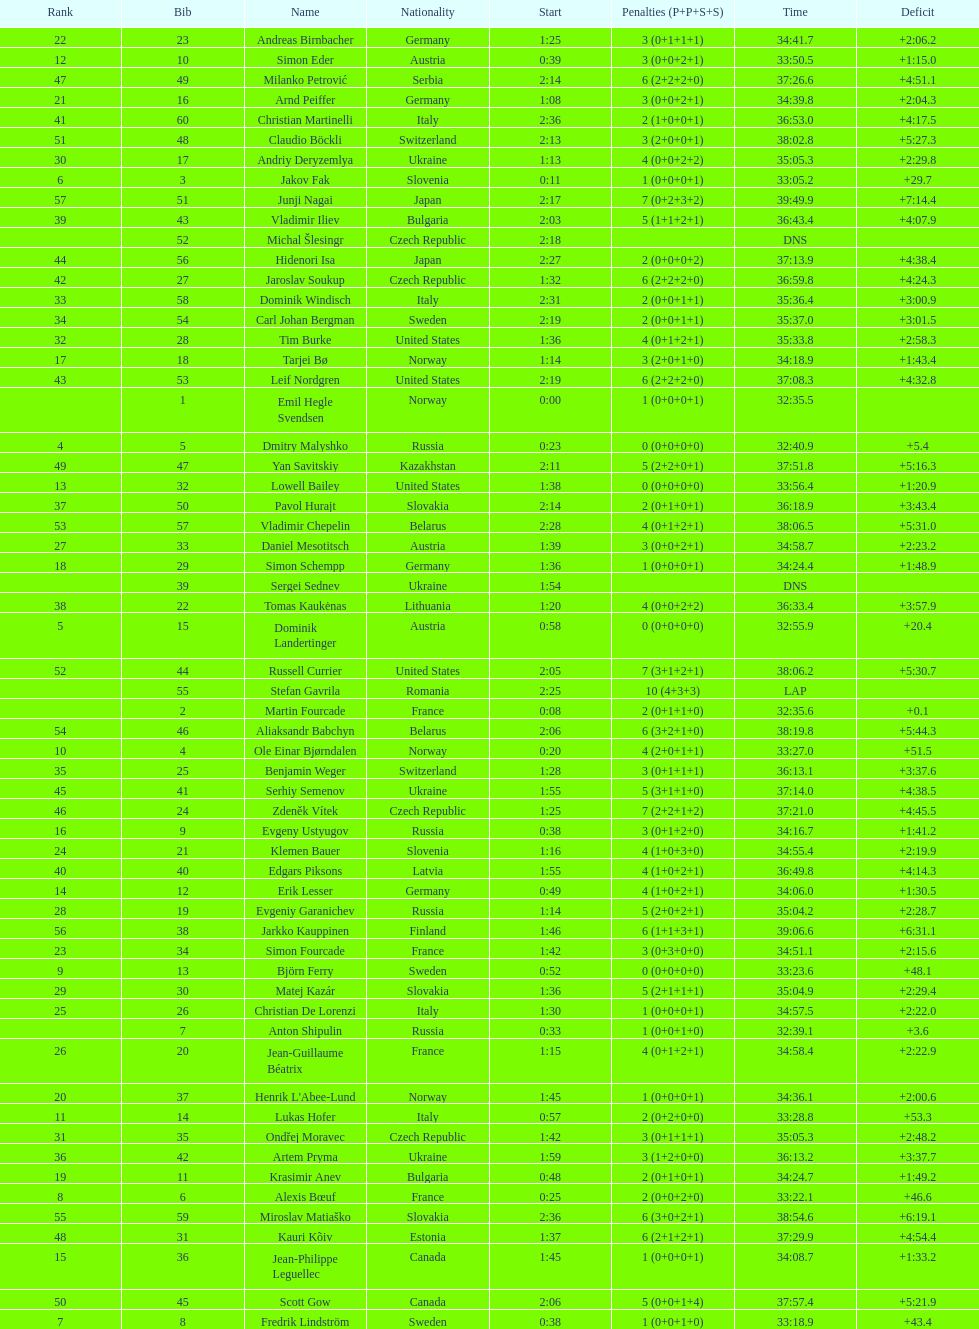Other than burke, name an athlete from the us. Leif Nordgren. Help me parse the entirety of this table. {'header': ['Rank', 'Bib', 'Name', 'Nationality', 'Start', 'Penalties (P+P+S+S)', 'Time', 'Deficit'], 'rows': [['22', '23', 'Andreas Birnbacher', 'Germany', '1:25', '3 (0+1+1+1)', '34:41.7', '+2:06.2'], ['12', '10', 'Simon Eder', 'Austria', '0:39', '3 (0+0+2+1)', '33:50.5', '+1:15.0'], ['47', '49', 'Milanko Petrović', 'Serbia', '2:14', '6 (2+2+2+0)', '37:26.6', '+4:51.1'], ['21', '16', 'Arnd Peiffer', 'Germany', '1:08', '3 (0+0+2+1)', '34:39.8', '+2:04.3'], ['41', '60', 'Christian Martinelli', 'Italy', '2:36', '2 (1+0+0+1)', '36:53.0', '+4:17.5'], ['51', '48', 'Claudio Böckli', 'Switzerland', '2:13', '3 (2+0+0+1)', '38:02.8', '+5:27.3'], ['30', '17', 'Andriy Deryzemlya', 'Ukraine', '1:13', '4 (0+0+2+2)', '35:05.3', '+2:29.8'], ['6', '3', 'Jakov Fak', 'Slovenia', '0:11', '1 (0+0+0+1)', '33:05.2', '+29.7'], ['57', '51', 'Junji Nagai', 'Japan', '2:17', '7 (0+2+3+2)', '39:49.9', '+7:14.4'], ['39', '43', 'Vladimir Iliev', 'Bulgaria', '2:03', '5 (1+1+2+1)', '36:43.4', '+4:07.9'], ['', '52', 'Michal Šlesingr', 'Czech Republic', '2:18', '', 'DNS', ''], ['44', '56', 'Hidenori Isa', 'Japan', '2:27', '2 (0+0+0+2)', '37:13.9', '+4:38.4'], ['42', '27', 'Jaroslav Soukup', 'Czech Republic', '1:32', '6 (2+2+2+0)', '36:59.8', '+4:24.3'], ['33', '58', 'Dominik Windisch', 'Italy', '2:31', '2 (0+0+1+1)', '35:36.4', '+3:00.9'], ['34', '54', 'Carl Johan Bergman', 'Sweden', '2:19', '2 (0+0+1+1)', '35:37.0', '+3:01.5'], ['32', '28', 'Tim Burke', 'United States', '1:36', '4 (0+1+2+1)', '35:33.8', '+2:58.3'], ['17', '18', 'Tarjei Bø', 'Norway', '1:14', '3 (2+0+1+0)', '34:18.9', '+1:43.4'], ['43', '53', 'Leif Nordgren', 'United States', '2:19', '6 (2+2+2+0)', '37:08.3', '+4:32.8'], ['', '1', 'Emil Hegle Svendsen', 'Norway', '0:00', '1 (0+0+0+1)', '32:35.5', ''], ['4', '5', 'Dmitry Malyshko', 'Russia', '0:23', '0 (0+0+0+0)', '32:40.9', '+5.4'], ['49', '47', 'Yan Savitskiy', 'Kazakhstan', '2:11', '5 (2+2+0+1)', '37:51.8', '+5:16.3'], ['13', '32', 'Lowell Bailey', 'United States', '1:38', '0 (0+0+0+0)', '33:56.4', '+1:20.9'], ['37', '50', 'Pavol Hurajt', 'Slovakia', '2:14', '2 (0+1+0+1)', '36:18.9', '+3:43.4'], ['53', '57', 'Vladimir Chepelin', 'Belarus', '2:28', '4 (0+1+2+1)', '38:06.5', '+5:31.0'], ['27', '33', 'Daniel Mesotitsch', 'Austria', '1:39', '3 (0+0+2+1)', '34:58.7', '+2:23.2'], ['18', '29', 'Simon Schempp', 'Germany', '1:36', '1 (0+0+0+1)', '34:24.4', '+1:48.9'], ['', '39', 'Sergei Sednev', 'Ukraine', '1:54', '', 'DNS', ''], ['38', '22', 'Tomas Kaukėnas', 'Lithuania', '1:20', '4 (0+0+2+2)', '36:33.4', '+3:57.9'], ['5', '15', 'Dominik Landertinger', 'Austria', '0:58', '0 (0+0+0+0)', '32:55.9', '+20.4'], ['52', '44', 'Russell Currier', 'United States', '2:05', '7 (3+1+2+1)', '38:06.2', '+5:30.7'], ['', '55', 'Stefan Gavrila', 'Romania', '2:25', '10 (4+3+3)', 'LAP', ''], ['', '2', 'Martin Fourcade', 'France', '0:08', '2 (0+1+1+0)', '32:35.6', '+0.1'], ['54', '46', 'Aliaksandr Babchyn', 'Belarus', '2:06', '6 (3+2+1+0)', '38:19.8', '+5:44.3'], ['10', '4', 'Ole Einar Bjørndalen', 'Norway', '0:20', '4 (2+0+1+1)', '33:27.0', '+51.5'], ['35', '25', 'Benjamin Weger', 'Switzerland', '1:28', '3 (0+1+1+1)', '36:13.1', '+3:37.6'], ['45', '41', 'Serhiy Semenov', 'Ukraine', '1:55', '5 (3+1+1+0)', '37:14.0', '+4:38.5'], ['46', '24', 'Zdeněk Vítek', 'Czech Republic', '1:25', '7 (2+2+1+2)', '37:21.0', '+4:45.5'], ['16', '9', 'Evgeny Ustyugov', 'Russia', '0:38', '3 (0+1+2+0)', '34:16.7', '+1:41.2'], ['24', '21', 'Klemen Bauer', 'Slovenia', '1:16', '4 (1+0+3+0)', '34:55.4', '+2:19.9'], ['40', '40', 'Edgars Piksons', 'Latvia', '1:55', '4 (1+0+2+1)', '36:49.8', '+4:14.3'], ['14', '12', 'Erik Lesser', 'Germany', '0:49', '4 (1+0+2+1)', '34:06.0', '+1:30.5'], ['28', '19', 'Evgeniy Garanichev', 'Russia', '1:14', '5 (2+0+2+1)', '35:04.2', '+2:28.7'], ['56', '38', 'Jarkko Kauppinen', 'Finland', '1:46', '6 (1+1+3+1)', '39:06.6', '+6:31.1'], ['23', '34', 'Simon Fourcade', 'France', '1:42', '3 (0+3+0+0)', '34:51.1', '+2:15.6'], ['9', '13', 'Björn Ferry', 'Sweden', '0:52', '0 (0+0+0+0)', '33:23.6', '+48.1'], ['29', '30', 'Matej Kazár', 'Slovakia', '1:36', '5 (2+1+1+1)', '35:04.9', '+2:29.4'], ['25', '26', 'Christian De Lorenzi', 'Italy', '1:30', '1 (0+0+0+1)', '34:57.5', '+2:22.0'], ['', '7', 'Anton Shipulin', 'Russia', '0:33', '1 (0+0+1+0)', '32:39.1', '+3.6'], ['26', '20', 'Jean-Guillaume Béatrix', 'France', '1:15', '4 (0+1+2+1)', '34:58.4', '+2:22.9'], ['20', '37', "Henrik L'Abee-Lund", 'Norway', '1:45', '1 (0+0+0+1)', '34:36.1', '+2:00.6'], ['11', '14', 'Lukas Hofer', 'Italy', '0:57', '2 (0+2+0+0)', '33:28.8', '+53.3'], ['31', '35', 'Ondřej Moravec', 'Czech Republic', '1:42', '3 (0+1+1+1)', '35:05.3', '+2:48.2'], ['36', '42', 'Artem Pryma', 'Ukraine', '1:59', '3 (1+2+0+0)', '36:13.2', '+3:37.7'], ['19', '11', 'Krasimir Anev', 'Bulgaria', '0:48', '2 (0+1+0+1)', '34:24.7', '+1:49.2'], ['8', '6', 'Alexis Bœuf', 'France', '0:25', '2 (0+0+2+0)', '33:22.1', '+46.6'], ['55', '59', 'Miroslav Matiaško', 'Slovakia', '2:36', '6 (3+0+2+1)', '38:54.6', '+6:19.1'], ['48', '31', 'Kauri Kõiv', 'Estonia', '1:37', '6 (2+1+2+1)', '37:29.9', '+4:54.4'], ['15', '36', 'Jean-Philippe Leguellec', 'Canada', '1:45', '1 (0+0+0+1)', '34:08.7', '+1:33.2'], ['50', '45', 'Scott Gow', 'Canada', '2:06', '5 (0+0+1+4)', '37:57.4', '+5:21.9'], ['7', '8', 'Fredrik Lindström', 'Sweden', '0:38', '1 (0+0+1+0)', '33:18.9', '+43.4']]} 